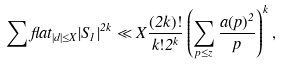<formula> <loc_0><loc_0><loc_500><loc_500>\sum f l a t _ { | d | \leq X } | S _ { 1 } | ^ { 2 k } \ll X \frac { ( 2 k ) ! } { k ! 2 ^ { k } } \left ( \sum _ { p \leq z } \frac { a ( p ) ^ { 2 } } { p } \right ) ^ { k } ,</formula> 